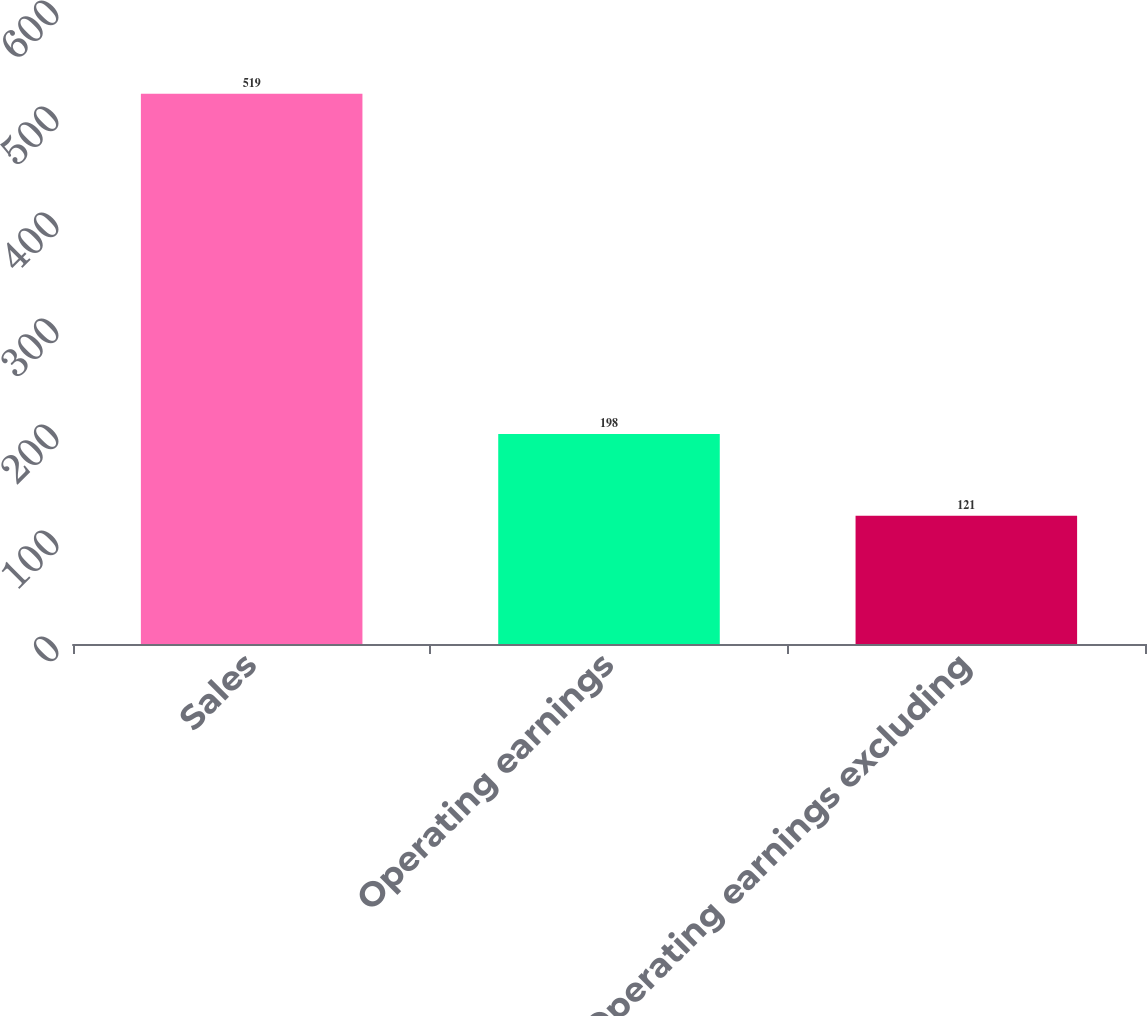Convert chart to OTSL. <chart><loc_0><loc_0><loc_500><loc_500><bar_chart><fcel>Sales<fcel>Operating earnings<fcel>Operating earnings excluding<nl><fcel>519<fcel>198<fcel>121<nl></chart> 